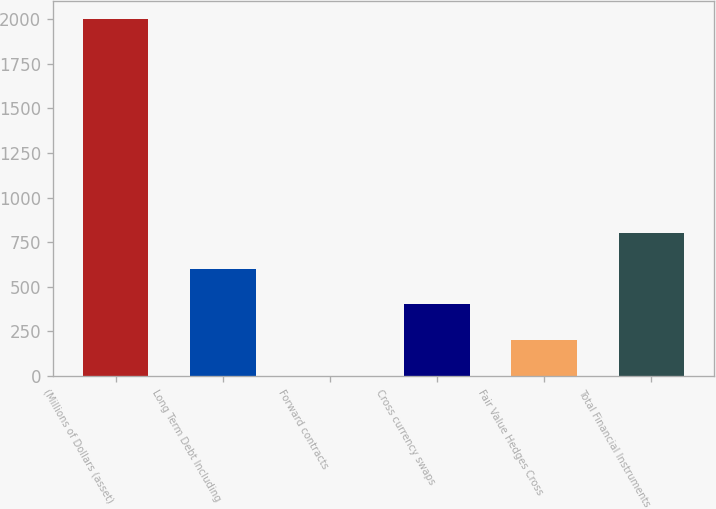<chart> <loc_0><loc_0><loc_500><loc_500><bar_chart><fcel>(Millions of Dollars (asset)<fcel>Long Term Debt Including<fcel>Forward contracts<fcel>Cross currency swaps<fcel>Fair Value Hedges Cross<fcel>Total Financial Instruments<nl><fcel>2004<fcel>601.27<fcel>0.1<fcel>400.88<fcel>200.49<fcel>801.66<nl></chart> 